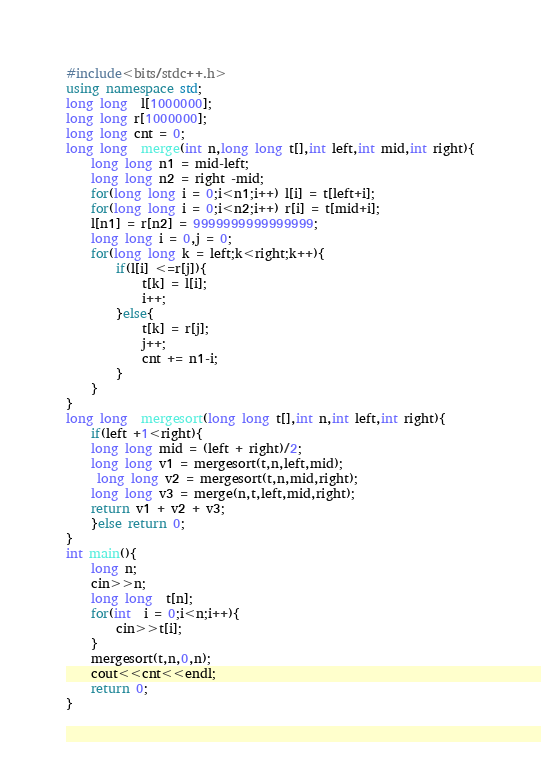Convert code to text. <code><loc_0><loc_0><loc_500><loc_500><_C++_>#include<bits/stdc++.h>
using namespace std;
long long  l[1000000];
long long r[1000000];
long long cnt = 0;
long long  merge(int n,long long t[],int left,int mid,int right){
	long long n1 = mid-left;
	long long n2 = right -mid;
	for(long long i = 0;i<n1;i++) l[i] = t[left+i];
	for(long long i = 0;i<n2;i++) r[i] = t[mid+i];
	l[n1] = r[n2] = 9999999999999999;
	long long i = 0,j = 0;
	for(long long k = left;k<right;k++){
		if(l[i] <=r[j]){
			t[k] = l[i];
			i++;
		}else{
			t[k] = r[j];
			j++;
			cnt += n1-i;
		}
	}
}
long long  mergesort(long long t[],int n,int left,int right){
	if(left +1<right){
	long long mid = (left + right)/2;
	long long v1 = mergesort(t,n,left,mid);
	 long long v2 = mergesort(t,n,mid,right);
	long long v3 = merge(n,t,left,mid,right);
	return v1 + v2 + v3;
	}else return 0;
}
int main(){
	long n;
	cin>>n;
	long long  t[n];
	for(int  i = 0;i<n;i++){
		cin>>t[i];
	}
	mergesort(t,n,0,n);
	cout<<cnt<<endl;
	return 0;
}
</code> 